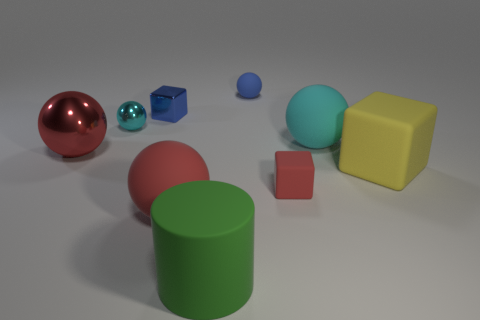How many big things are on the left side of the big yellow rubber block and on the right side of the small blue shiny object? There are three large objects situated to the left of the big yellow rubber block and to the right of the small blue shiny object. These are a large red sphere, a large green cylinder, and a large cyan-colored sphere. 